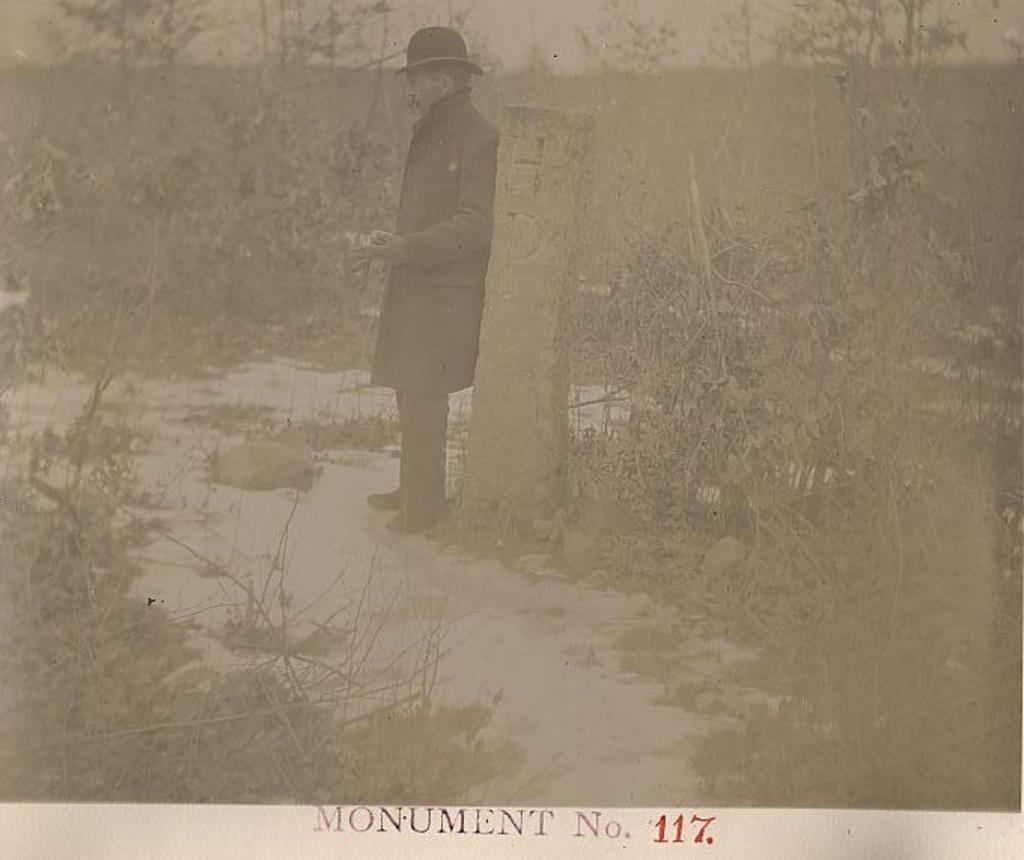In one or two sentences, can you explain what this image depicts? In the center of the image we can see a man standing. He is wearing a coat and a hat. There is a pillar. In the background we can see trees. 